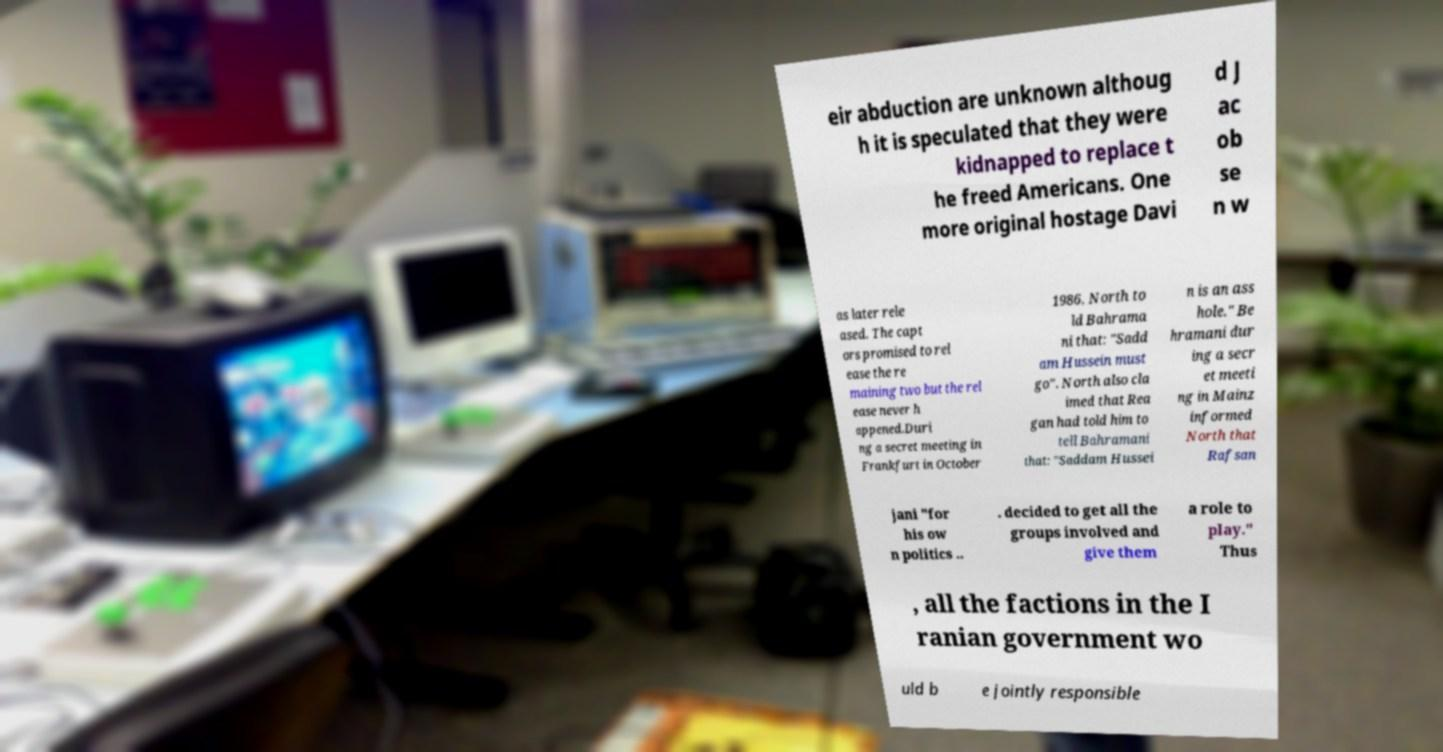For documentation purposes, I need the text within this image transcribed. Could you provide that? eir abduction are unknown althoug h it is speculated that they were kidnapped to replace t he freed Americans. One more original hostage Davi d J ac ob se n w as later rele ased. The capt ors promised to rel ease the re maining two but the rel ease never h appened.Duri ng a secret meeting in Frankfurt in October 1986, North to ld Bahrama ni that: "Sadd am Hussein must go". North also cla imed that Rea gan had told him to tell Bahramani that: "Saddam Hussei n is an ass hole." Be hramani dur ing a secr et meeti ng in Mainz informed North that Rafsan jani "for his ow n politics .. . decided to get all the groups involved and give them a role to play." Thus , all the factions in the I ranian government wo uld b e jointly responsible 